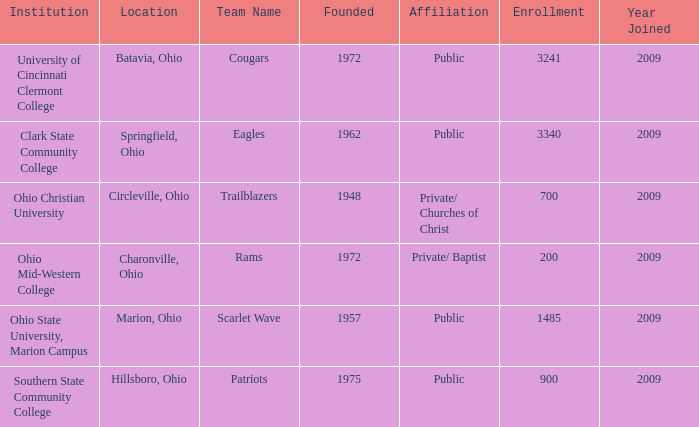What is the count of founded entries with springfield, ohio as their location? 1.0. 